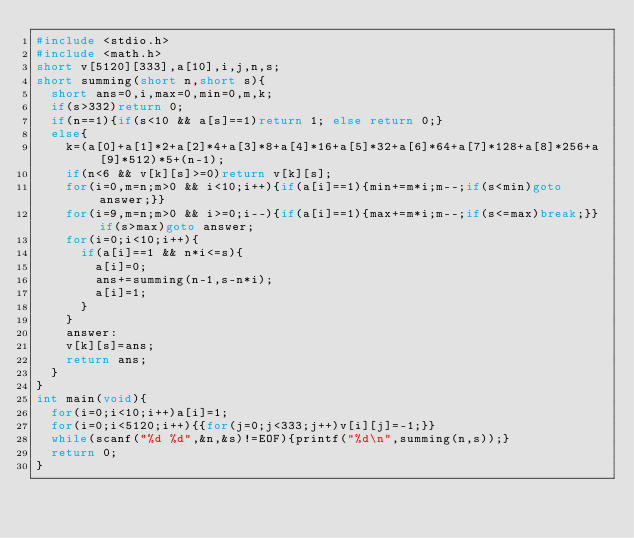Convert code to text. <code><loc_0><loc_0><loc_500><loc_500><_C_>#include <stdio.h>
#include <math.h>
short v[5120][333],a[10],i,j,n,s;
short summing(short n,short s){
	short ans=0,i,max=0,min=0,m,k;
	if(s>332)return 0;
	if(n==1){if(s<10 && a[s]==1)return 1; else return 0;}
	else{
		k=(a[0]+a[1]*2+a[2]*4+a[3]*8+a[4]*16+a[5]*32+a[6]*64+a[7]*128+a[8]*256+a[9]*512)*5+(n-1);
		if(n<6 && v[k][s]>=0)return v[k][s];
		for(i=0,m=n;m>0 && i<10;i++){if(a[i]==1){min+=m*i;m--;if(s<min)goto answer;}}
		for(i=9,m=n;m>0 && i>=0;i--){if(a[i]==1){max+=m*i;m--;if(s<=max)break;}}if(s>max)goto answer;
		for(i=0;i<10;i++){
			if(a[i]==1 && n*i<=s){
				a[i]=0;
				ans+=summing(n-1,s-n*i);
				a[i]=1;
			}
		}
		answer:
		v[k][s]=ans;
		return ans;
	}
}
int main(void){
	for(i=0;i<10;i++)a[i]=1;
	for(i=0;i<5120;i++){{for(j=0;j<333;j++)v[i][j]=-1;}}
	while(scanf("%d %d",&n,&s)!=EOF){printf("%d\n",summing(n,s));}
	return 0;
}</code> 